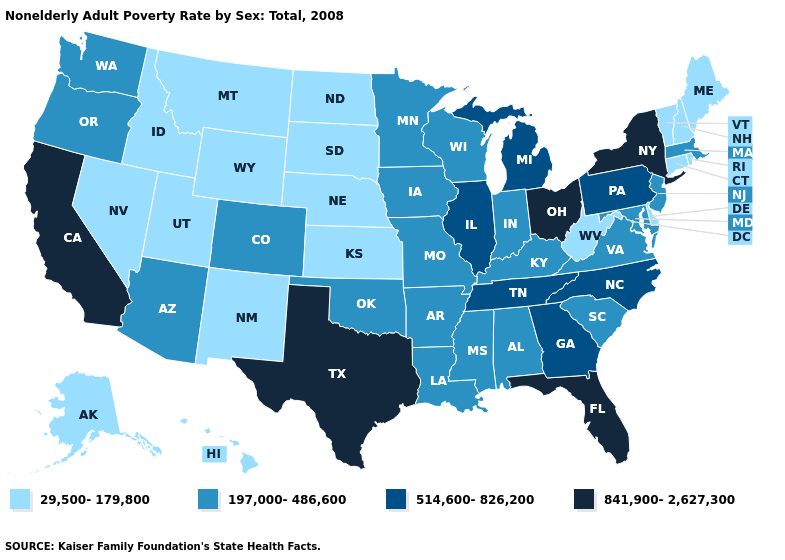Name the states that have a value in the range 29,500-179,800?
Write a very short answer. Alaska, Connecticut, Delaware, Hawaii, Idaho, Kansas, Maine, Montana, Nebraska, Nevada, New Hampshire, New Mexico, North Dakota, Rhode Island, South Dakota, Utah, Vermont, West Virginia, Wyoming. What is the highest value in the West ?
Answer briefly. 841,900-2,627,300. What is the value of Oregon?
Keep it brief. 197,000-486,600. What is the highest value in the West ?
Write a very short answer. 841,900-2,627,300. Name the states that have a value in the range 197,000-486,600?
Give a very brief answer. Alabama, Arizona, Arkansas, Colorado, Indiana, Iowa, Kentucky, Louisiana, Maryland, Massachusetts, Minnesota, Mississippi, Missouri, New Jersey, Oklahoma, Oregon, South Carolina, Virginia, Washington, Wisconsin. Name the states that have a value in the range 514,600-826,200?
Write a very short answer. Georgia, Illinois, Michigan, North Carolina, Pennsylvania, Tennessee. Which states have the lowest value in the USA?
Short answer required. Alaska, Connecticut, Delaware, Hawaii, Idaho, Kansas, Maine, Montana, Nebraska, Nevada, New Hampshire, New Mexico, North Dakota, Rhode Island, South Dakota, Utah, Vermont, West Virginia, Wyoming. What is the highest value in states that border Vermont?
Short answer required. 841,900-2,627,300. Does Ohio have the lowest value in the MidWest?
Be succinct. No. What is the value of Oregon?
Keep it brief. 197,000-486,600. Among the states that border Vermont , which have the highest value?
Short answer required. New York. What is the value of West Virginia?
Keep it brief. 29,500-179,800. Which states have the lowest value in the USA?
Write a very short answer. Alaska, Connecticut, Delaware, Hawaii, Idaho, Kansas, Maine, Montana, Nebraska, Nevada, New Hampshire, New Mexico, North Dakota, Rhode Island, South Dakota, Utah, Vermont, West Virginia, Wyoming. Does North Dakota have the lowest value in the MidWest?
Write a very short answer. Yes. Does Rhode Island have a higher value than Missouri?
Be succinct. No. 